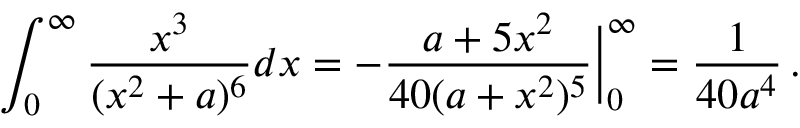<formula> <loc_0><loc_0><loc_500><loc_500>\int _ { 0 } ^ { \infty } \frac { x ^ { 3 } } { ( x ^ { 2 } + a ) ^ { 6 } } d x = - \frac { a + 5 x ^ { 2 } } { 4 0 ( a + x ^ { 2 } ) ^ { 5 } } \Big | _ { 0 } ^ { \infty } = \frac { 1 } { 4 0 a ^ { 4 } } \, .</formula> 